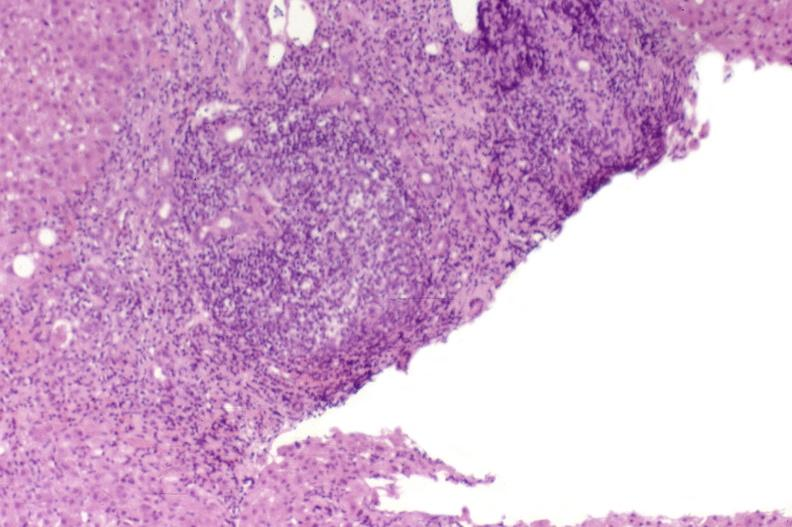what is present?
Answer the question using a single word or phrase. Hepatobiliary 